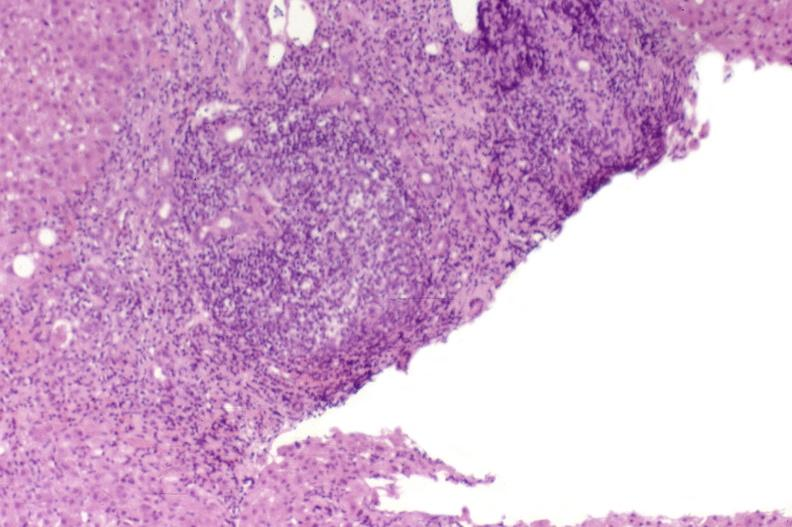what is present?
Answer the question using a single word or phrase. Hepatobiliary 